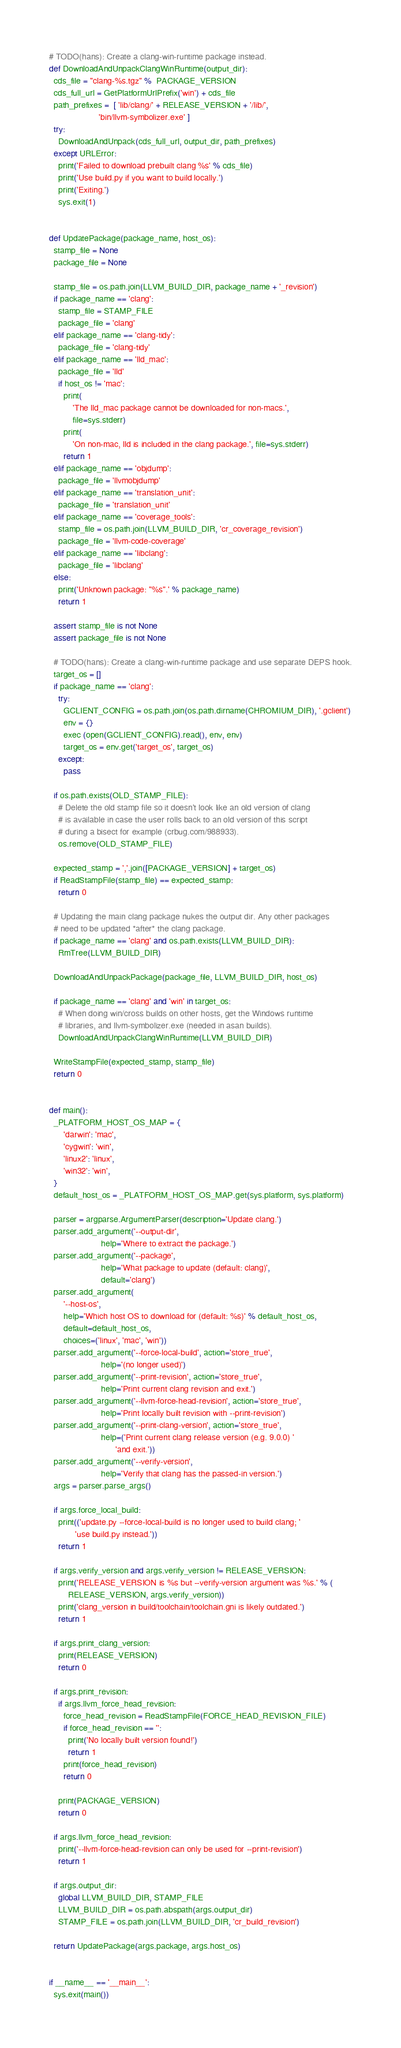Convert code to text. <code><loc_0><loc_0><loc_500><loc_500><_Python_>

# TODO(hans): Create a clang-win-runtime package instead.
def DownloadAndUnpackClangWinRuntime(output_dir):
  cds_file = "clang-%s.tgz" %  PACKAGE_VERSION
  cds_full_url = GetPlatformUrlPrefix('win') + cds_file
  path_prefixes =  [ 'lib/clang/' + RELEASE_VERSION + '/lib/',
                     'bin/llvm-symbolizer.exe' ]
  try:
    DownloadAndUnpack(cds_full_url, output_dir, path_prefixes)
  except URLError:
    print('Failed to download prebuilt clang %s' % cds_file)
    print('Use build.py if you want to build locally.')
    print('Exiting.')
    sys.exit(1)


def UpdatePackage(package_name, host_os):
  stamp_file = None
  package_file = None

  stamp_file = os.path.join(LLVM_BUILD_DIR, package_name + '_revision')
  if package_name == 'clang':
    stamp_file = STAMP_FILE
    package_file = 'clang'
  elif package_name == 'clang-tidy':
    package_file = 'clang-tidy'
  elif package_name == 'lld_mac':
    package_file = 'lld'
    if host_os != 'mac':
      print(
          'The lld_mac package cannot be downloaded for non-macs.',
          file=sys.stderr)
      print(
          'On non-mac, lld is included in the clang package.', file=sys.stderr)
      return 1
  elif package_name == 'objdump':
    package_file = 'llvmobjdump'
  elif package_name == 'translation_unit':
    package_file = 'translation_unit'
  elif package_name == 'coverage_tools':
    stamp_file = os.path.join(LLVM_BUILD_DIR, 'cr_coverage_revision')
    package_file = 'llvm-code-coverage'
  elif package_name == 'libclang':
    package_file = 'libclang'
  else:
    print('Unknown package: "%s".' % package_name)
    return 1

  assert stamp_file is not None
  assert package_file is not None

  # TODO(hans): Create a clang-win-runtime package and use separate DEPS hook.
  target_os = []
  if package_name == 'clang':
    try:
      GCLIENT_CONFIG = os.path.join(os.path.dirname(CHROMIUM_DIR), '.gclient')
      env = {}
      exec (open(GCLIENT_CONFIG).read(), env, env)
      target_os = env.get('target_os', target_os)
    except:
      pass

  if os.path.exists(OLD_STAMP_FILE):
    # Delete the old stamp file so it doesn't look like an old version of clang
    # is available in case the user rolls back to an old version of this script
    # during a bisect for example (crbug.com/988933).
    os.remove(OLD_STAMP_FILE)

  expected_stamp = ','.join([PACKAGE_VERSION] + target_os)
  if ReadStampFile(stamp_file) == expected_stamp:
    return 0

  # Updating the main clang package nukes the output dir. Any other packages
  # need to be updated *after* the clang package.
  if package_name == 'clang' and os.path.exists(LLVM_BUILD_DIR):
    RmTree(LLVM_BUILD_DIR)

  DownloadAndUnpackPackage(package_file, LLVM_BUILD_DIR, host_os)

  if package_name == 'clang' and 'win' in target_os:
    # When doing win/cross builds on other hosts, get the Windows runtime
    # libraries, and llvm-symbolizer.exe (needed in asan builds).
    DownloadAndUnpackClangWinRuntime(LLVM_BUILD_DIR)

  WriteStampFile(expected_stamp, stamp_file)
  return 0


def main():
  _PLATFORM_HOST_OS_MAP = {
      'darwin': 'mac',
      'cygwin': 'win',
      'linux2': 'linux',
      'win32': 'win',
  }
  default_host_os = _PLATFORM_HOST_OS_MAP.get(sys.platform, sys.platform)

  parser = argparse.ArgumentParser(description='Update clang.')
  parser.add_argument('--output-dir',
                      help='Where to extract the package.')
  parser.add_argument('--package',
                      help='What package to update (default: clang)',
                      default='clang')
  parser.add_argument(
      '--host-os',
      help='Which host OS to download for (default: %s)' % default_host_os,
      default=default_host_os,
      choices=('linux', 'mac', 'win'))
  parser.add_argument('--force-local-build', action='store_true',
                      help='(no longer used)')
  parser.add_argument('--print-revision', action='store_true',
                      help='Print current clang revision and exit.')
  parser.add_argument('--llvm-force-head-revision', action='store_true',
                      help='Print locally built revision with --print-revision')
  parser.add_argument('--print-clang-version', action='store_true',
                      help=('Print current clang release version (e.g. 9.0.0) '
                            'and exit.'))
  parser.add_argument('--verify-version',
                      help='Verify that clang has the passed-in version.')
  args = parser.parse_args()

  if args.force_local_build:
    print(('update.py --force-local-build is no longer used to build clang; '
           'use build.py instead.'))
    return 1

  if args.verify_version and args.verify_version != RELEASE_VERSION:
    print('RELEASE_VERSION is %s but --verify-version argument was %s.' % (
        RELEASE_VERSION, args.verify_version))
    print('clang_version in build/toolchain/toolchain.gni is likely outdated.')
    return 1

  if args.print_clang_version:
    print(RELEASE_VERSION)
    return 0

  if args.print_revision:
    if args.llvm_force_head_revision:
      force_head_revision = ReadStampFile(FORCE_HEAD_REVISION_FILE)
      if force_head_revision == '':
        print('No locally built version found!')
        return 1
      print(force_head_revision)
      return 0

    print(PACKAGE_VERSION)
    return 0

  if args.llvm_force_head_revision:
    print('--llvm-force-head-revision can only be used for --print-revision')
    return 1

  if args.output_dir:
    global LLVM_BUILD_DIR, STAMP_FILE
    LLVM_BUILD_DIR = os.path.abspath(args.output_dir)
    STAMP_FILE = os.path.join(LLVM_BUILD_DIR, 'cr_build_revision')

  return UpdatePackage(args.package, args.host_os)


if __name__ == '__main__':
  sys.exit(main())
</code> 